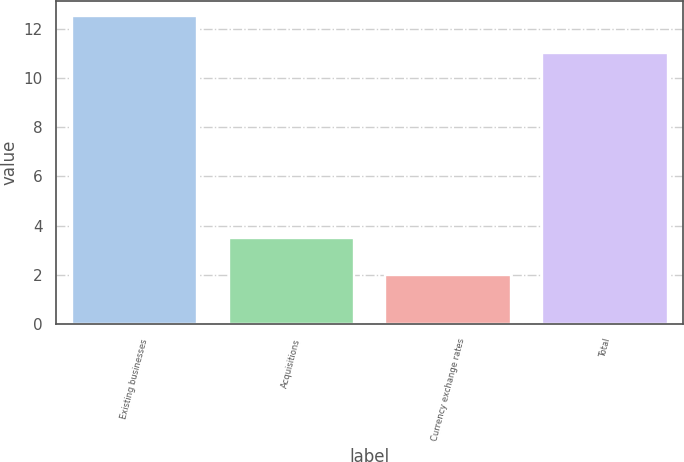Convert chart. <chart><loc_0><loc_0><loc_500><loc_500><bar_chart><fcel>Existing businesses<fcel>Acquisitions<fcel>Currency exchange rates<fcel>Total<nl><fcel>12.5<fcel>3.5<fcel>2<fcel>11<nl></chart> 